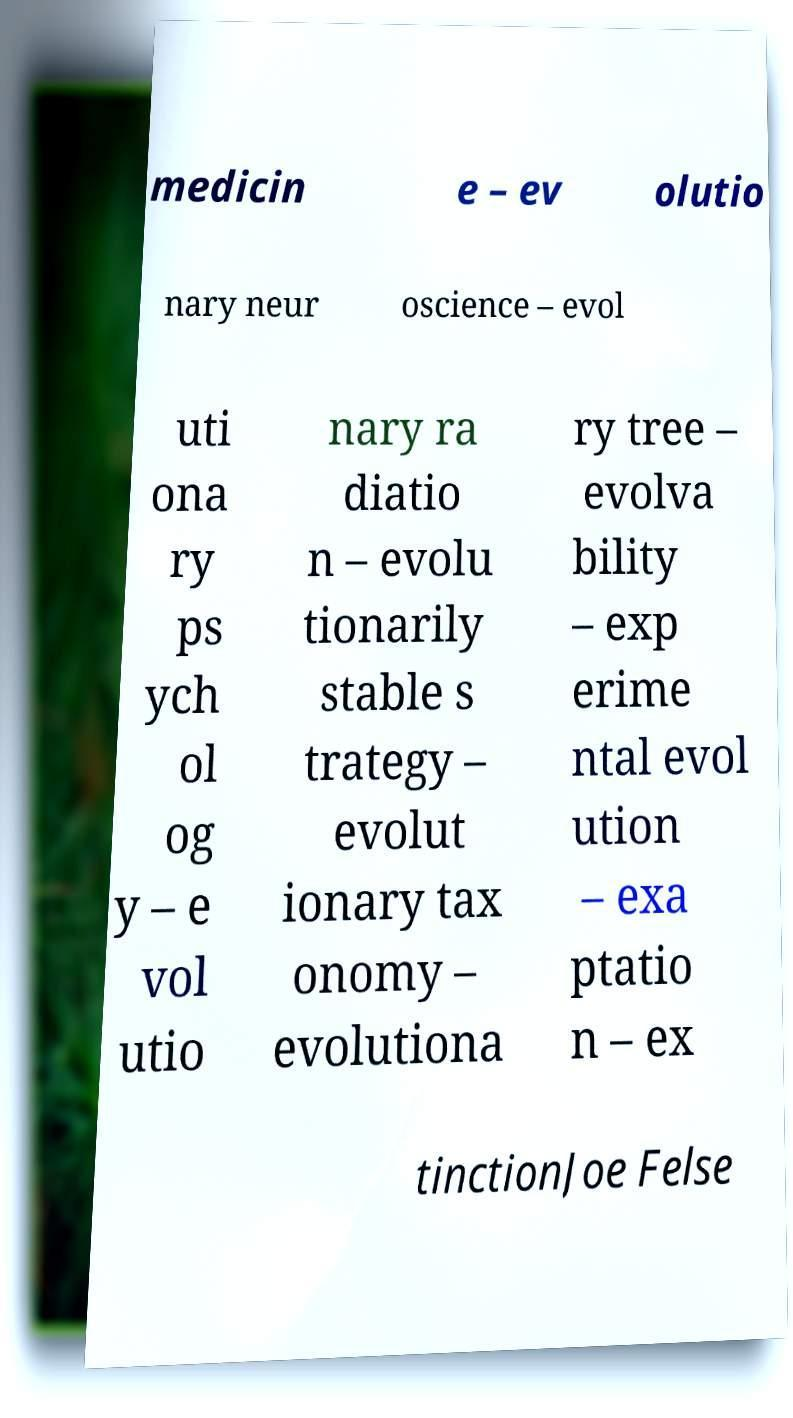There's text embedded in this image that I need extracted. Can you transcribe it verbatim? medicin e – ev olutio nary neur oscience – evol uti ona ry ps ych ol og y – e vol utio nary ra diatio n – evolu tionarily stable s trategy – evolut ionary tax onomy – evolutiona ry tree – evolva bility – exp erime ntal evol ution – exa ptatio n – ex tinctionJoe Felse 